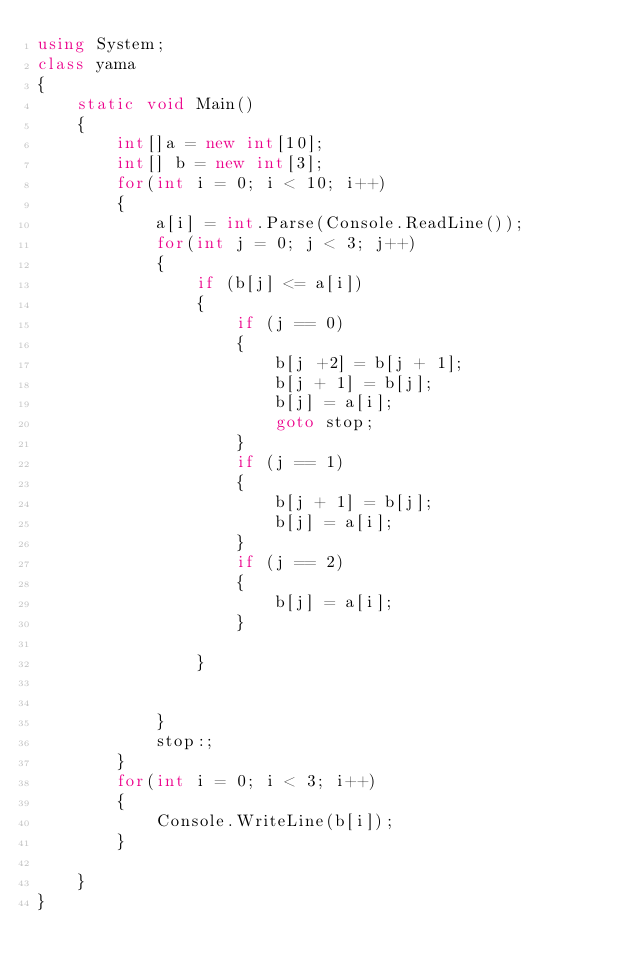<code> <loc_0><loc_0><loc_500><loc_500><_C#_>using System;
class yama
{
    static void Main()
    {
        int[]a = new int[10];
        int[] b = new int[3];
        for(int i = 0; i < 10; i++)
        {
            a[i] = int.Parse(Console.ReadLine());
            for(int j = 0; j < 3; j++)
            {
                if (b[j] <= a[i])
                {
                    if (j == 0)
                    {
                        b[j +2] = b[j + 1];
                        b[j + 1] = b[j];
                        b[j] = a[i];
                        goto stop;
                    }
                    if (j == 1)
                    {
                        b[j + 1] = b[j];
                        b[j] = a[i];
                    }
                    if (j == 2)
                    {
                        b[j] = a[i];
                    }
                    
                }
                

            }
            stop:;
        }
        for(int i = 0; i < 3; i++)
        {
            Console.WriteLine(b[i]);
        }

    }
}</code> 